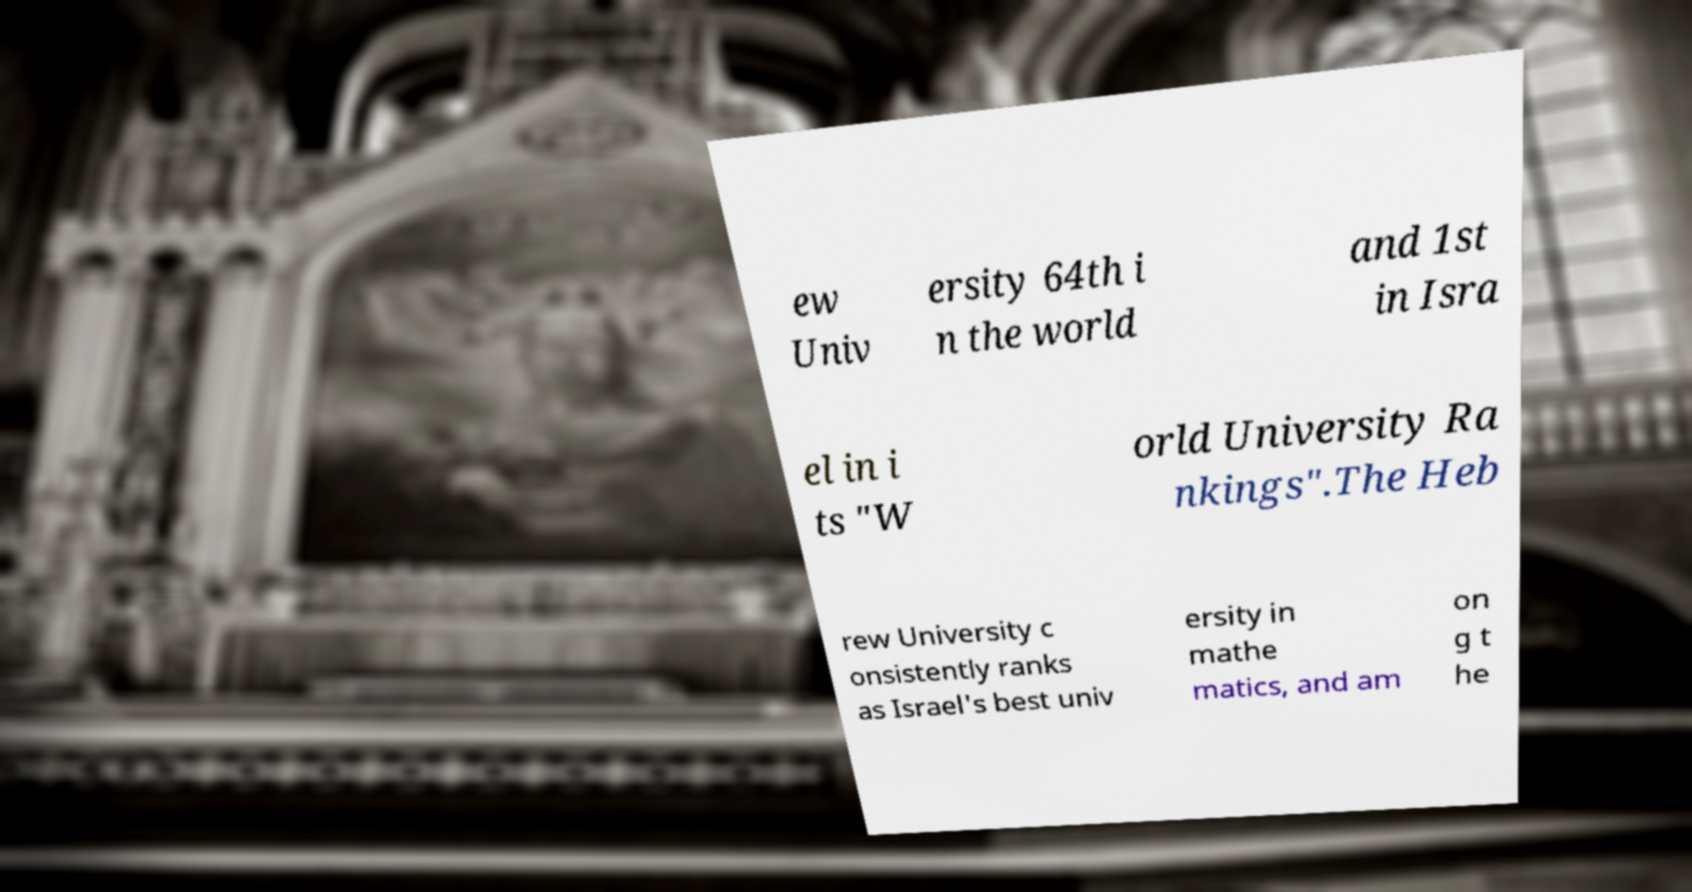Can you accurately transcribe the text from the provided image for me? ew Univ ersity 64th i n the world and 1st in Isra el in i ts "W orld University Ra nkings".The Heb rew University c onsistently ranks as Israel's best univ ersity in mathe matics, and am on g t he 